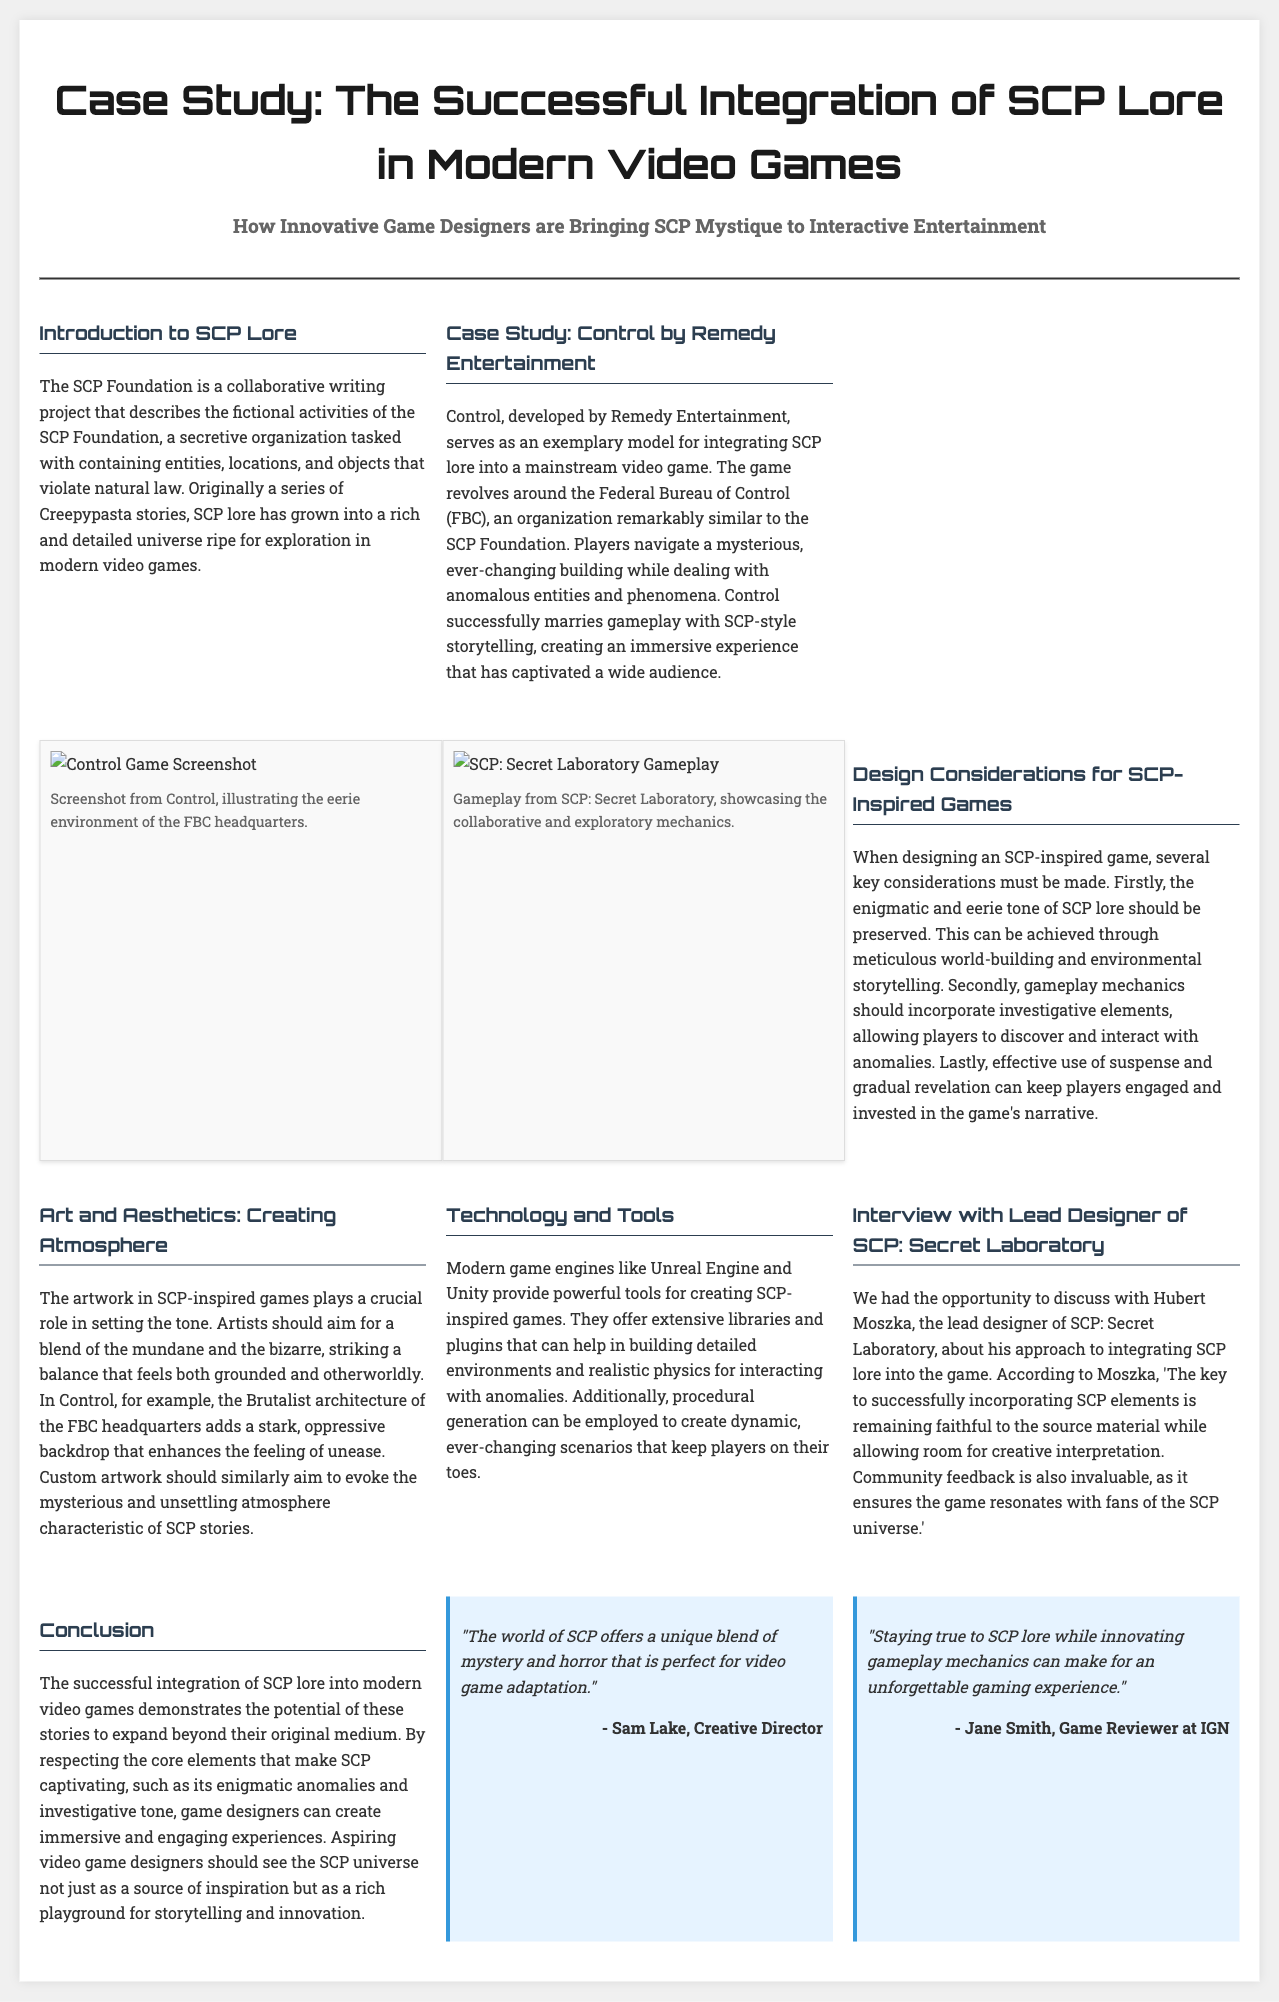What is the main focus of the article? The article discusses the integration of SCP lore into modern video games, particularly how innovative game designers are bringing this lore to interactive entertainment.
Answer: Integration of SCP lore in modern video games Who developed the game highlighted as a case study? The case study discusses the game Control, which was developed by Remedy Entertainment.
Answer: Remedy Entertainment What organization is similar to the SCP Foundation in the game Control? The Federal Bureau of Control (FBC) is highlighted as being remarkably similar to the SCP Foundation.
Answer: Federal Bureau of Control What fictional project inspired SCP lore? The SCP Foundation originated as a collaborative writing project derived from a series of Creepypasta stories.
Answer: Creepypasta stories What is a key design consideration for SCP-inspired games? One key consideration for SCP-inspired games is to preserve the enigmatic and eerie tone of SCP lore.
Answer: Eerie tone Who is the lead designer of SCP: Secret Laboratory interviewed in the article? Hubert Moszka is mentioned as the lead designer of SCP: Secret Laboratory.
Answer: Hubert Moszka What artistic style enhances the atmosphere in SCP-inspired games according to the article? The article recommends balancing the mundane and the bizarre in artwork to create the right atmosphere.
Answer: Mundane and bizarre What quote did Sam Lake provide regarding the SCP universe? Sam Lake stated that "The world of SCP offers a unique blend of mystery and horror that is perfect for video game adaptation."
Answer: Unique blend of mystery and horror What modern game engines are mentioned for creating SCP-inspired games? The article mentions Unreal Engine and Unity as powerful tools for creating SCP-inspired games.
Answer: Unreal Engine and Unity 